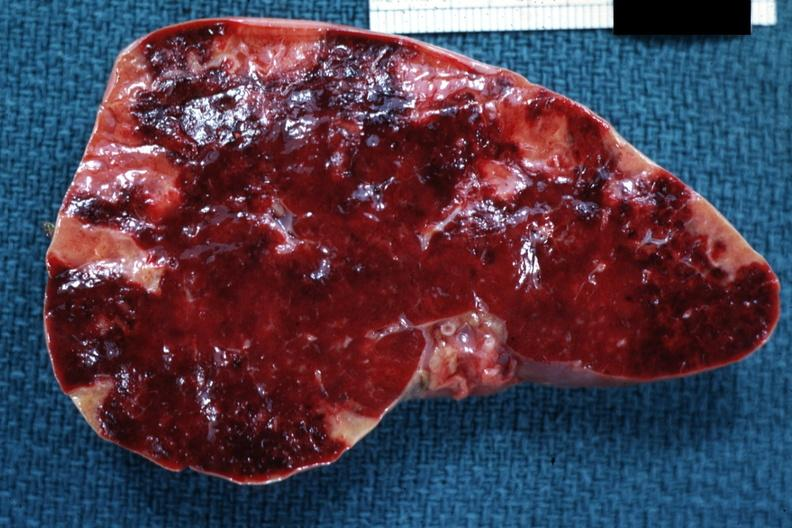does myocardium show cut surface of spleen with multiple recent infarcts very good example?
Answer the question using a single word or phrase. No 